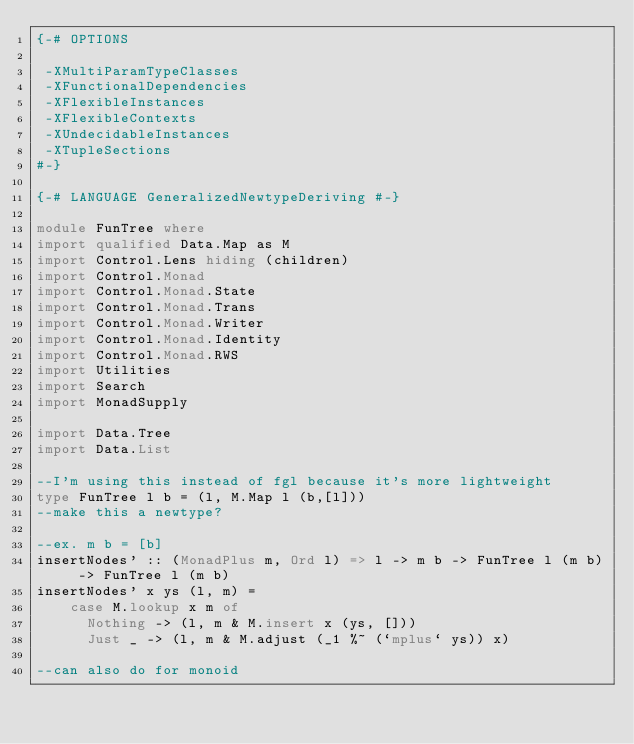<code> <loc_0><loc_0><loc_500><loc_500><_Haskell_>{-# OPTIONS
 
 -XMultiParamTypeClasses
 -XFunctionalDependencies
 -XFlexibleInstances
 -XFlexibleContexts
 -XUndecidableInstances
 -XTupleSections
#-}

{-# LANGUAGE GeneralizedNewtypeDeriving #-}

module FunTree where
import qualified Data.Map as M
import Control.Lens hiding (children)
import Control.Monad
import Control.Monad.State
import Control.Monad.Trans
import Control.Monad.Writer
import Control.Monad.Identity
import Control.Monad.RWS
import Utilities
import Search
import MonadSupply

import Data.Tree
import Data.List

--I'm using this instead of fgl because it's more lightweight
type FunTree l b = (l, M.Map l (b,[l]))
--make this a newtype?

--ex. m b = [b]
insertNodes' :: (MonadPlus m, Ord l) => l -> m b -> FunTree l (m b) -> FunTree l (m b)
insertNodes' x ys (l, m) = 
    case M.lookup x m of
      Nothing -> (l, m & M.insert x (ys, []))
      Just _ -> (l, m & M.adjust (_1 %~ (`mplus` ys)) x)

--can also do for monoid</code> 